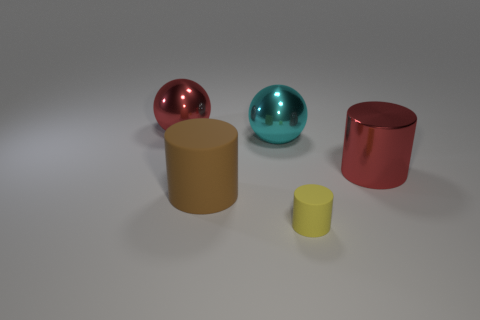What number of cylinders are brown things or large brown metal objects?
Your answer should be very brief. 1. Is there any other thing that is the same shape as the yellow rubber object?
Your answer should be very brief. Yes. Are there more yellow matte objects in front of the tiny yellow rubber thing than large shiny things that are behind the large brown cylinder?
Make the answer very short. No. How many tiny matte cylinders are to the left of the large red metal ball behind the large red metal cylinder?
Your answer should be very brief. 0. What number of things are either yellow matte cylinders or brown rubber cylinders?
Offer a terse response. 2. Is the large matte thing the same shape as the tiny rubber object?
Provide a succinct answer. Yes. What is the large brown cylinder made of?
Your answer should be very brief. Rubber. What number of objects are behind the big cyan shiny sphere and in front of the red metal sphere?
Keep it short and to the point. 0. Do the red cylinder and the yellow matte object have the same size?
Provide a short and direct response. No. There is a ball in front of the red sphere; is its size the same as the small yellow rubber thing?
Your answer should be very brief. No. 